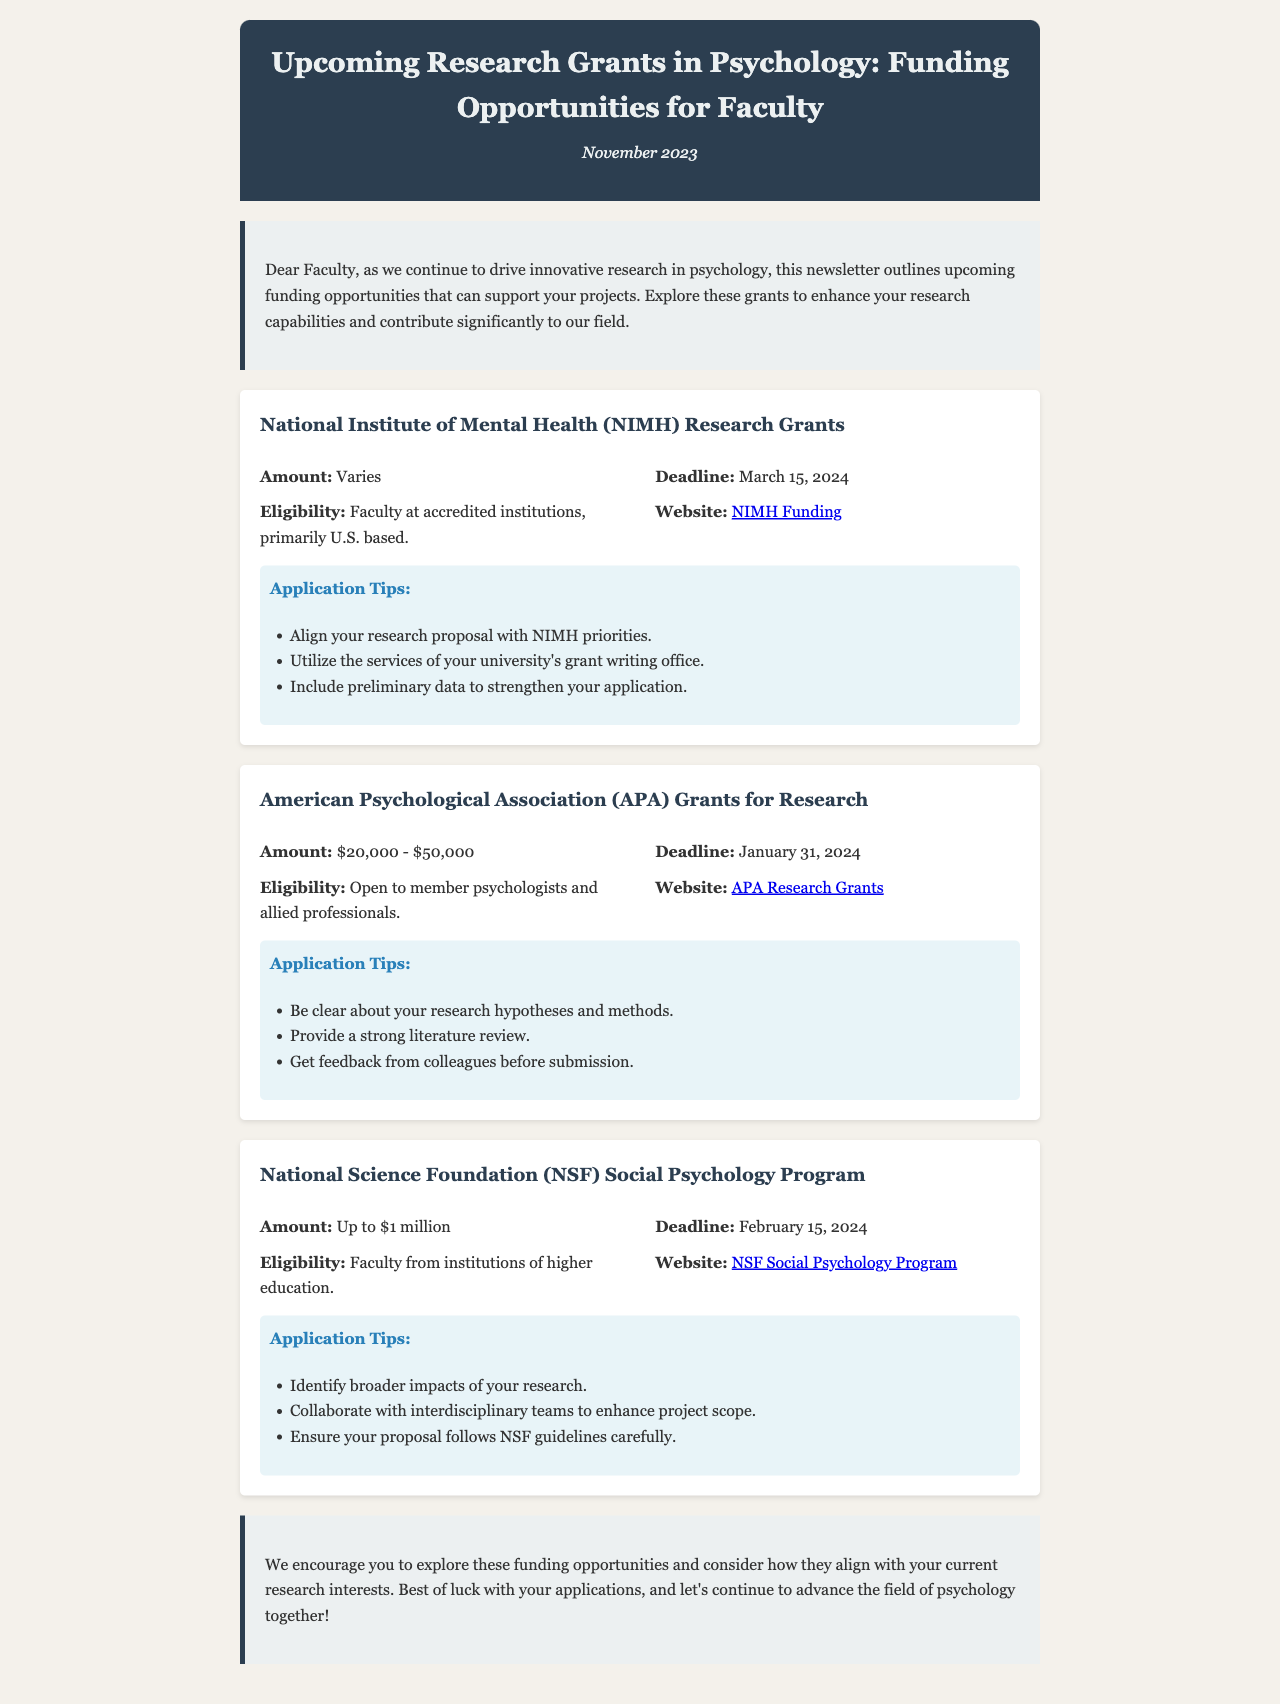What is the deadline for NIMH Research Grants? The document states that the deadline for NIMH Research Grants is March 15, 2024.
Answer: March 15, 2024 What is the funding range for APA Grants for Research? The funding range provided in the document for APA Grants is between $20,000 and $50,000.
Answer: $20,000 - $50,000 Who is eligible for NSF Social Psychology Program grants? According to the document, eligibility is for faculty from institutions of higher education.
Answer: Faculty from institutions of higher education What is one application tip for NIMH Research Grants? The document mentions aligning your research proposal with NIMH priorities as a tip for the application.
Answer: Align your research proposal with NIMH priorities What is the total maximum amount available for NSF Social Psychology Program grants? The document indicates that the maximum amount available is up to $1 million.
Answer: Up to $1 million What organization provides grants for open member psychologists? The document specifies that the American Psychological Association (APA) provides grants for member psychologists.
Answer: American Psychological Association (APA) What funding opportunity has a deadline before February 2024? The American Psychological Association (APA) Grants for Research has a deadline of January 31, 2024, which is before February.
Answer: January 31, 2024 What is the main purpose of this newsletter? The newsletter aims to outline upcoming funding opportunities to support research projects in psychology.
Answer: Outline upcoming funding opportunities 